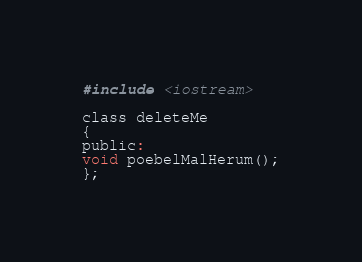Convert code to text. <code><loc_0><loc_0><loc_500><loc_500><_C_>#include <iostream>

class deleteMe
{
public:
void poebelMalHerum();
};
</code> 